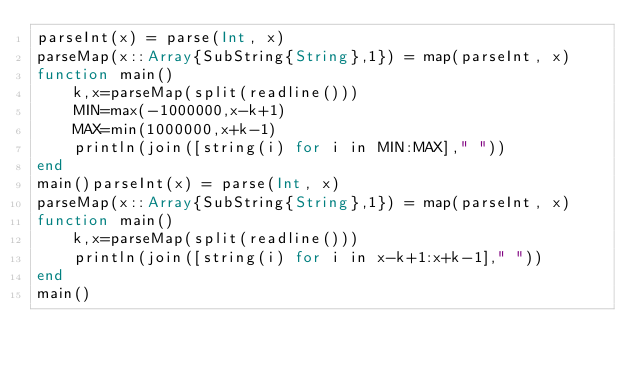Convert code to text. <code><loc_0><loc_0><loc_500><loc_500><_Julia_>parseInt(x) = parse(Int, x)
parseMap(x::Array{SubString{String},1}) = map(parseInt, x)
function main()
    k,x=parseMap(split(readline()))
    MIN=max(-1000000,x-k+1)
    MAX=min(1000000,x+k-1)
    println(join([string(i) for i in MIN:MAX]," "))
end
main()parseInt(x) = parse(Int, x)
parseMap(x::Array{SubString{String},1}) = map(parseInt, x)
function main()
    k,x=parseMap(split(readline()))
    println(join([string(i) for i in x-k+1:x+k-1]," "))
end
main()</code> 